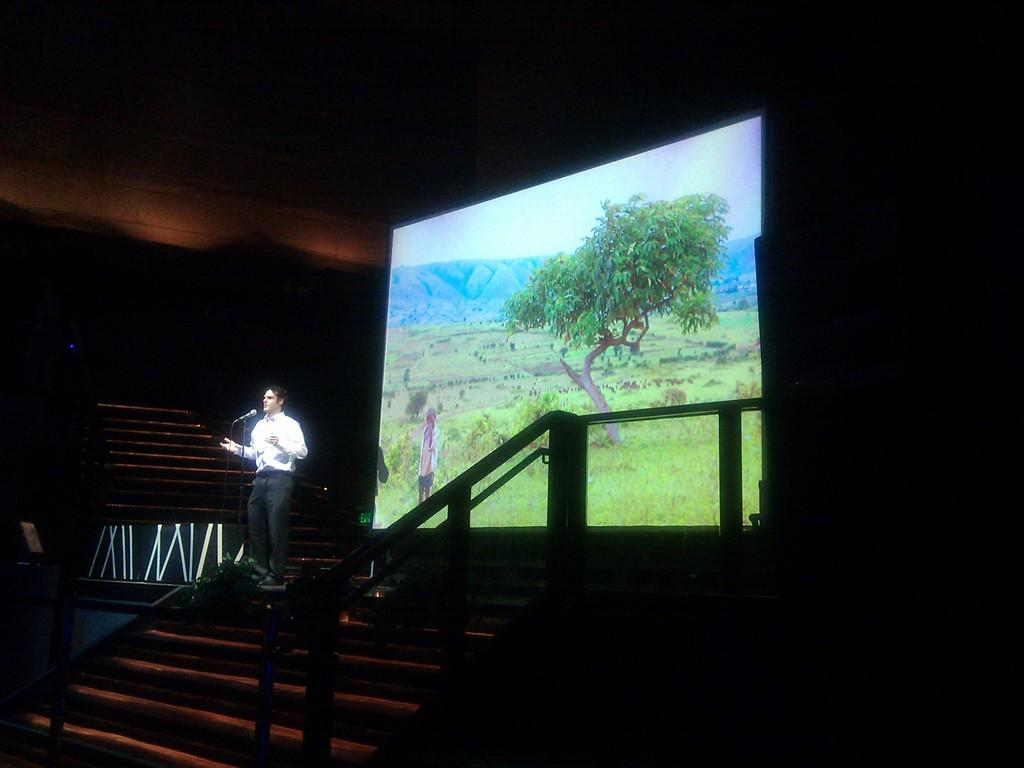What is the man in the image doing? The man is standing in the image and holding a microphone. What is visible behind the man? There is a screen behind the man, displaying a person, trees, grass, and sky. What is the overall lighting condition in the image? The background of the image appears dark. Can you see any plants with tails in the image? There are no plants or animals with tails present in the image. 